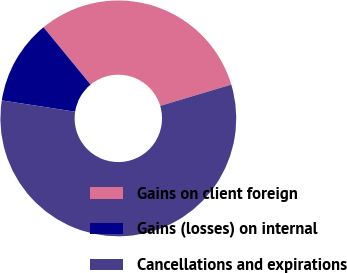Convert chart to OTSL. <chart><loc_0><loc_0><loc_500><loc_500><pie_chart><fcel>Gains on client foreign<fcel>Gains (losses) on internal<fcel>Cancellations and expirations<nl><fcel>31.32%<fcel>11.62%<fcel>57.07%<nl></chart> 